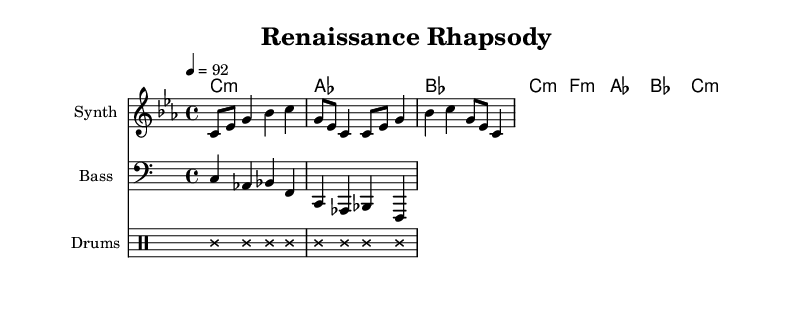What is the key signature of this music? The key signature is C minor, which is indicated by three flat symbols on the staff, corresponding to B flat, E flat, and A flat.
Answer: C minor What is the time signature of this music? The time signature is 4/4, which means there are four beats in each measure and the quarter note gets one beat. This is indicated at the beginning of the score.
Answer: 4/4 What is the tempo marking of the piece? The tempo marking shows that the piece should be played at a speed of 92 beats per minute as denoted by the number above the staff.
Answer: 92 How many measures are in the melody? The melody consists of two measures, as observed in the structure of the notes presented, each separated by a vertical bar in the score.
Answer: 2 What instruments are featured in this score? The score features a Synth for the melody, Bass for the bass line, and Drums for the percussion section, as labeled at the beginning of each staff.
Answer: Synth, Bass, Drums What is the style of the drum notes? The drum notes are marked with cross note heads and have transparent stems, indicating a unique style specific to drumming notation.
Answer: Cross style How does the harmony support the melody? The harmonies create a harmonic foundation underneath the melody by using chords that complement and enhance the pitches in the melody, creating a fuller sound.
Answer: Supportive chords 